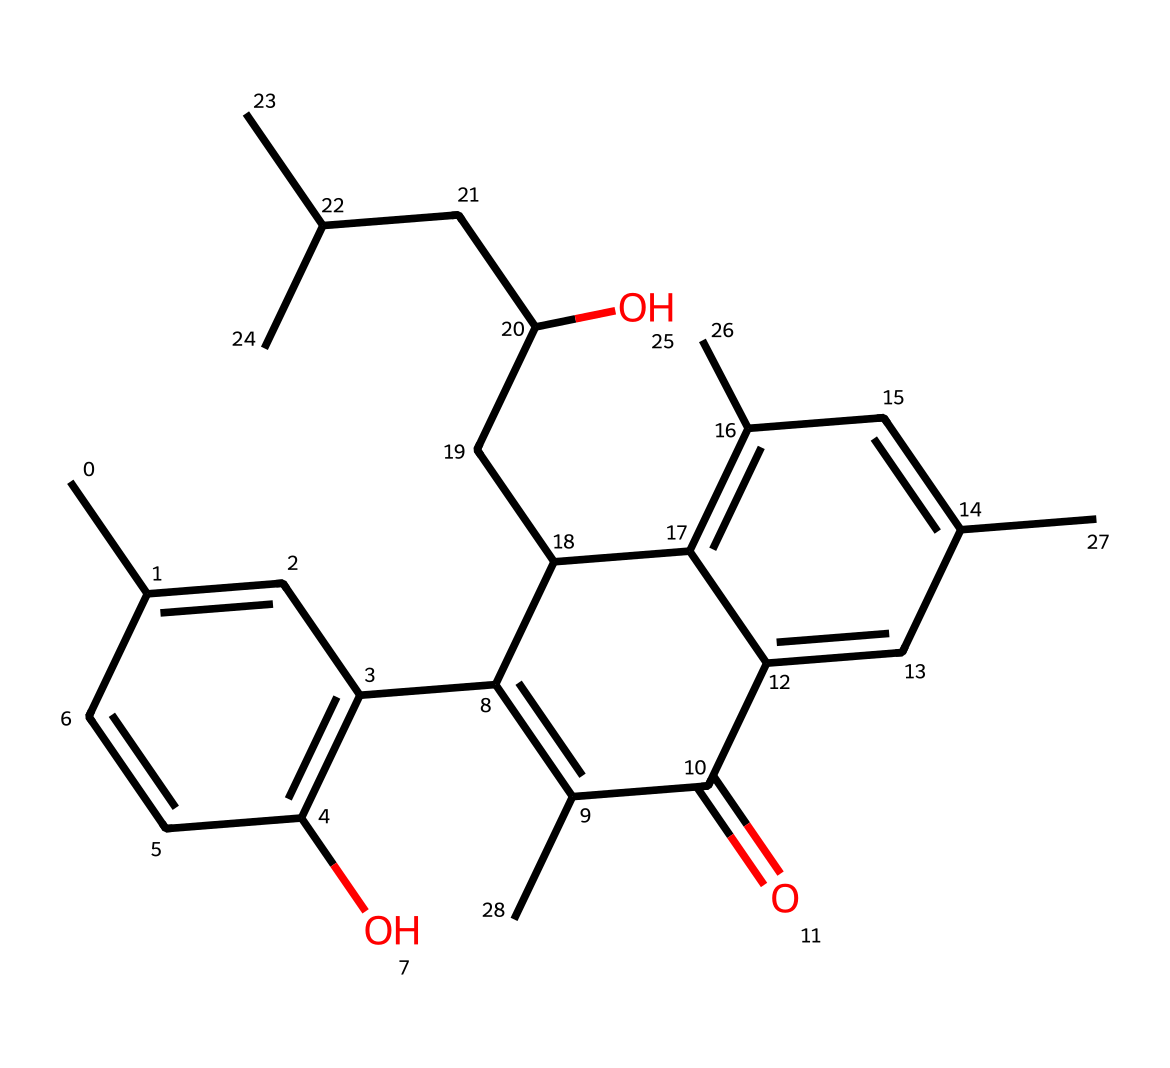What is the molecular formula of this chemical? To determine the molecular formula, one needs to count the number of each type of atom present in the SMILES representation. The atoms include carbon (C), hydrogen (H), and oxygen (O). After analyzing the structure, we find that there are 27 carbon atoms, 42 hydrogen atoms, and 2 oxygen atoms, resulting in the molecular formula C27H42O2.
Answer: C27H42O2 How many rings are present in the chemical structure? By examining the SMILES representation, we can identify the rings in the structure by looking for the numbers that denote ring closures. There are two instances of '1' indicating a ring closure and a '2' indicating another ring closure, totaling two rings.
Answer: 2 What type of drug is represented by this chemical? This chemical belongs to the category of cannabinoids, specifically THC, which is known for its psychoactive properties. This categorization is based on its structural features and historical context in pharmacology.
Answer: cannabinoids What does the presence of hydroxyl (–OH) groups indicate about this compound? The presence of hydroxyl groups in a compound often indicates that it has alcohol functionality, which contributes to its solubility in water and its potential pharmacological effects. In the context of THC, these hydroxyl groups play a role in its interaction with biological systems.
Answer: alcohol What is the significance of the double bonds in this chemical structure? Double bonds in organic molecules like this one, specifically in the carbon backbone, contribute to the overall reactivity and stability of the molecule. They can influence the drug's biological activity and how it interacts with receptors in the body, which is particularly relevant for THC's psychoactive effects.
Answer: reactivity How does the molecular complexity of this drug relate to its psychoactive effects? The complexity of the molecular structure, including branching and functional groups, allows for diverse interactions with cannabinoid receptors in the brain. This structural diversity is key to the potency and variety of effects produced by the drug.
Answer: structural diversity 